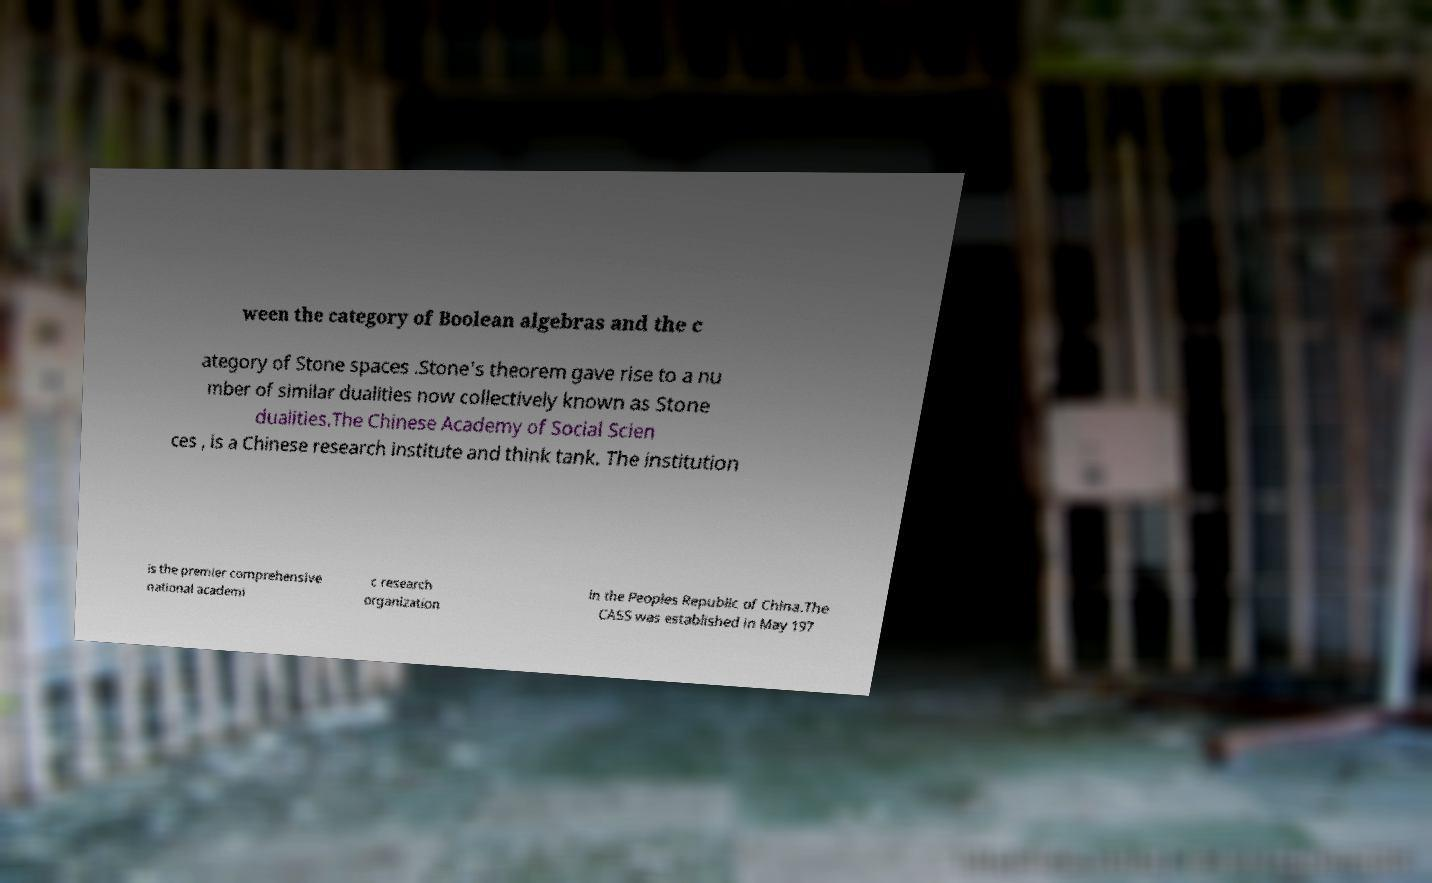There's text embedded in this image that I need extracted. Can you transcribe it verbatim? ween the category of Boolean algebras and the c ategory of Stone spaces .Stone's theorem gave rise to a nu mber of similar dualities now collectively known as Stone dualities.The Chinese Academy of Social Scien ces , is a Chinese research institute and think tank. The institution is the premier comprehensive national academi c research organization in the Peoples Republic of China.The CASS was established in May 197 